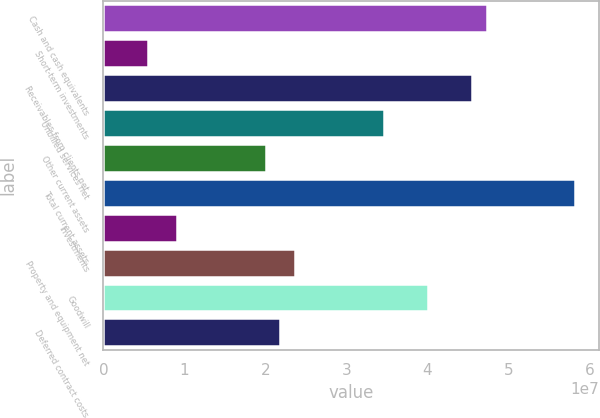Convert chart to OTSL. <chart><loc_0><loc_0><loc_500><loc_500><bar_chart><fcel>Cash and cash equivalents<fcel>Short-term investments<fcel>Receivables from clients net<fcel>Unbilled services net<fcel>Other current assets<fcel>Total current assets<fcel>Investments<fcel>Property and equipment net<fcel>Goodwill<fcel>Deferred contract costs<nl><fcel>4.73269e+07<fcel>5.46081e+06<fcel>4.55066e+07<fcel>3.4585e+07<fcel>2.00229e+07<fcel>5.82484e+07<fcel>9.10133e+06<fcel>2.36634e+07<fcel>4.00458e+07<fcel>2.18432e+07<nl></chart> 